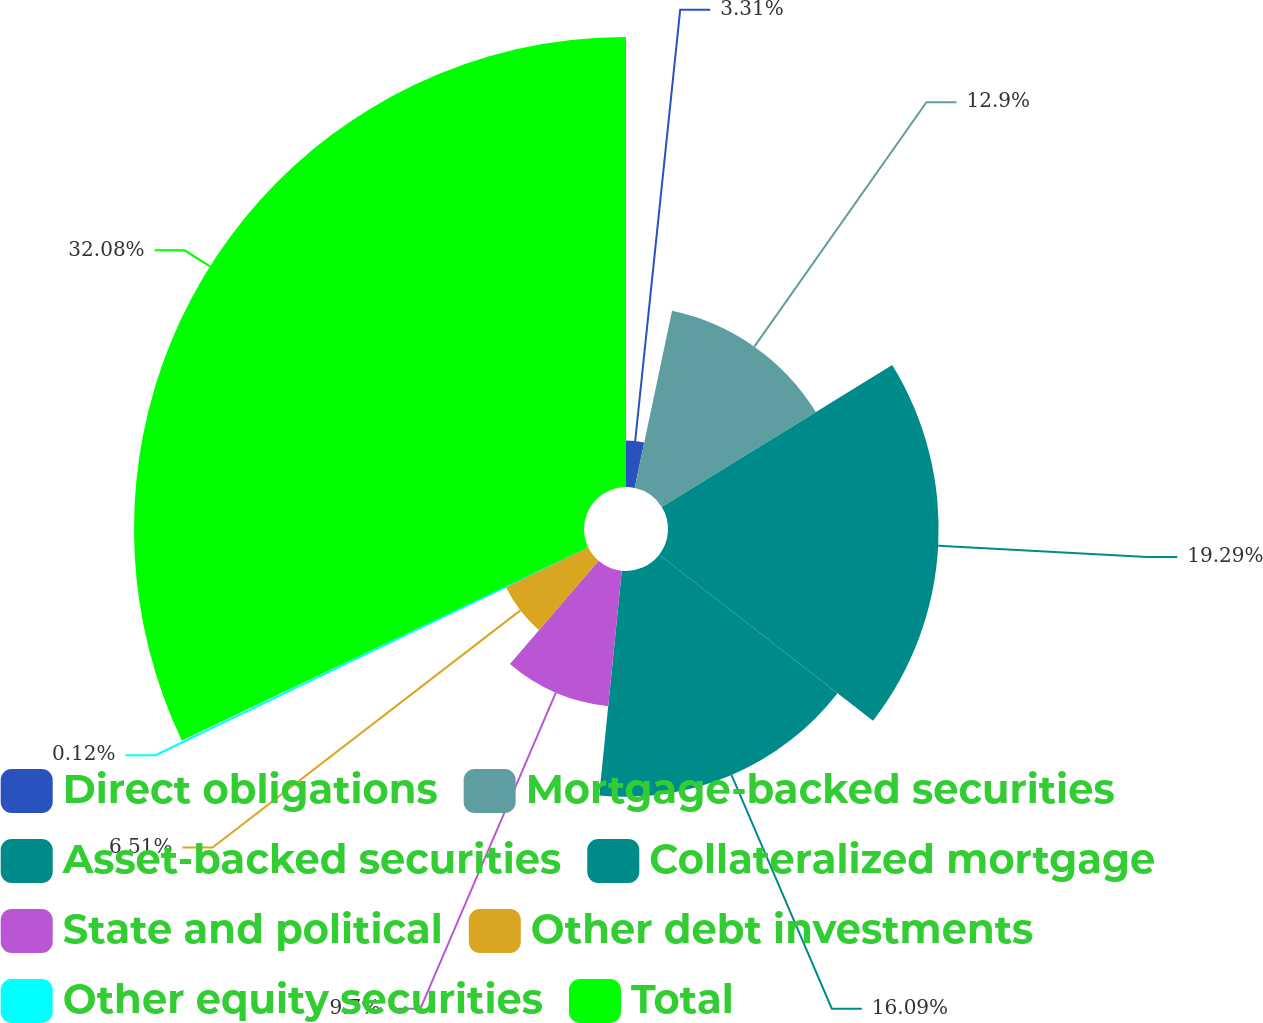Convert chart. <chart><loc_0><loc_0><loc_500><loc_500><pie_chart><fcel>Direct obligations<fcel>Mortgage-backed securities<fcel>Asset-backed securities<fcel>Collateralized mortgage<fcel>State and political<fcel>Other debt investments<fcel>Other equity securities<fcel>Total<nl><fcel>3.31%<fcel>12.9%<fcel>19.29%<fcel>16.09%<fcel>9.7%<fcel>6.51%<fcel>0.12%<fcel>32.07%<nl></chart> 